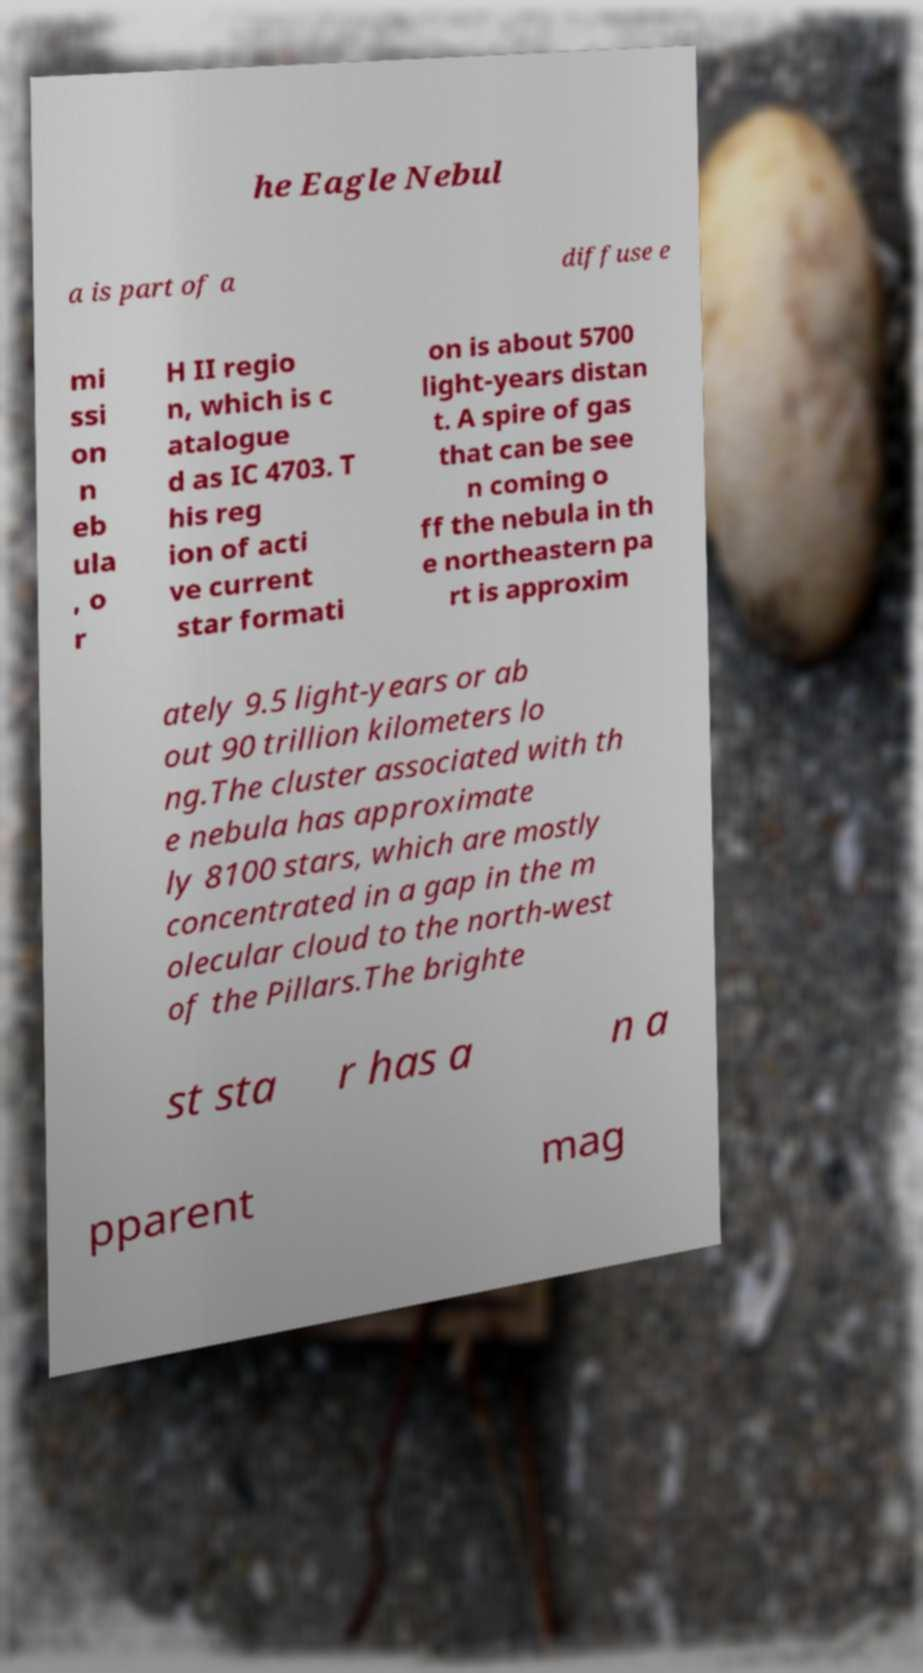Please read and relay the text visible in this image. What does it say? he Eagle Nebul a is part of a diffuse e mi ssi on n eb ula , o r H II regio n, which is c atalogue d as IC 4703. T his reg ion of acti ve current star formati on is about 5700 light-years distan t. A spire of gas that can be see n coming o ff the nebula in th e northeastern pa rt is approxim ately 9.5 light-years or ab out 90 trillion kilometers lo ng.The cluster associated with th e nebula has approximate ly 8100 stars, which are mostly concentrated in a gap in the m olecular cloud to the north-west of the Pillars.The brighte st sta r has a n a pparent mag 